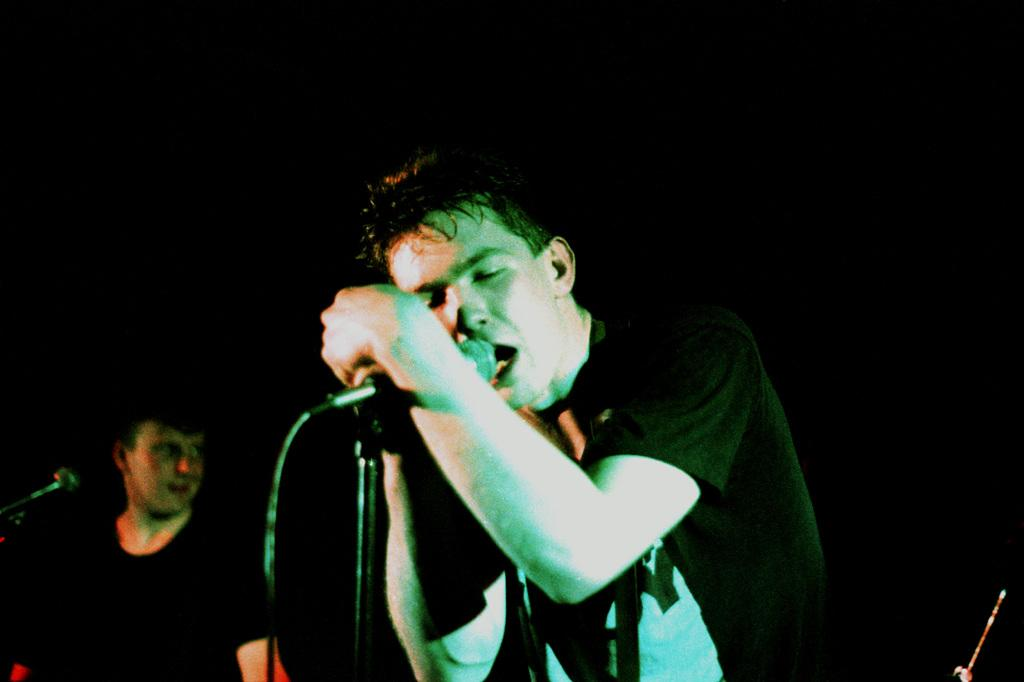How many people are in the image? There are two persons in the image. What objects are in front of the persons? There are microphones in front of the persons. What is one of the persons doing? One of the persons is singing. What type of dinosaurs can be seen in the image? There are no dinosaurs present in the image. What is the person doing with the drawer in the image? There is no drawer present in the image. 